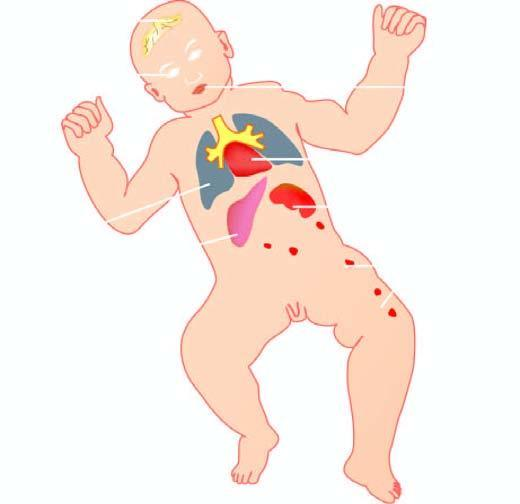what is produced by torch complex infection in foetus in utero?
Answer the question using a single word or phrase. Lesions 